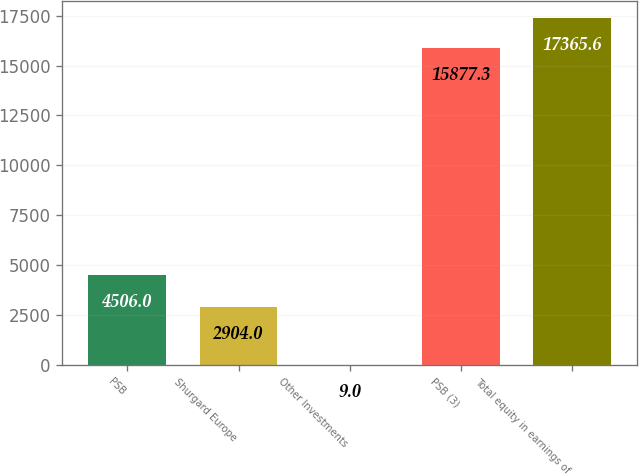Convert chart. <chart><loc_0><loc_0><loc_500><loc_500><bar_chart><fcel>PSB<fcel>Shurgard Europe<fcel>Other Investments<fcel>PSB (3)<fcel>Total equity in earnings of<nl><fcel>4506<fcel>2904<fcel>9<fcel>15877.3<fcel>17365.6<nl></chart> 